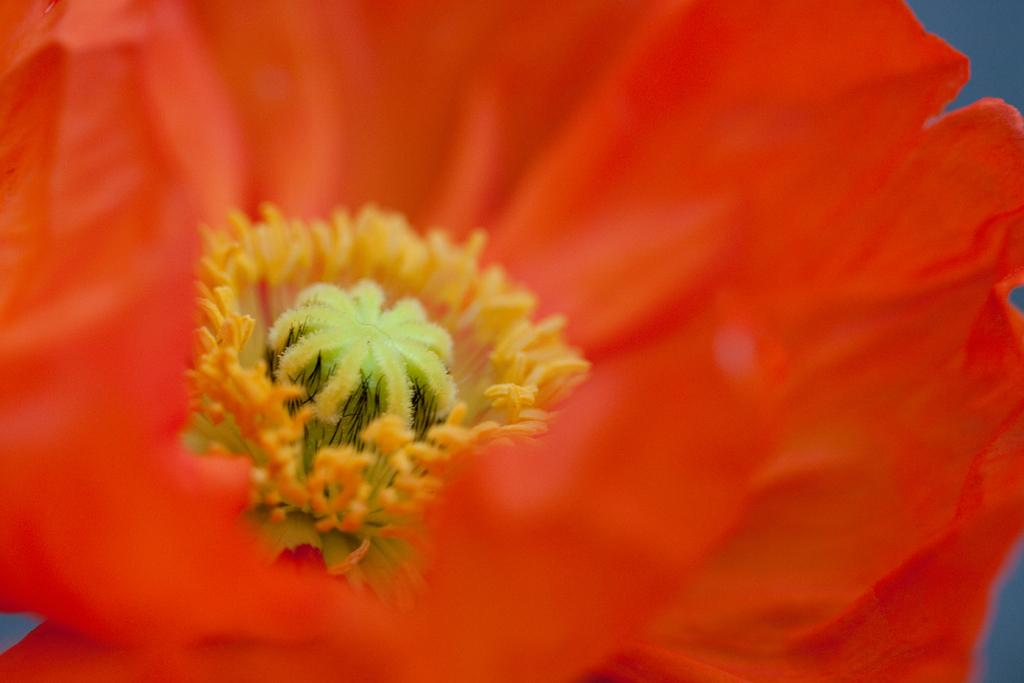What is the main subject of the image? The main subject of the image is a flower. What can be found in the center of the flower? The flower has pollen grains in the center. What surrounds the center of the flower? The flower has petals around it. How much salt is present on the flower in the image? There is no salt present on the flower in the image. 